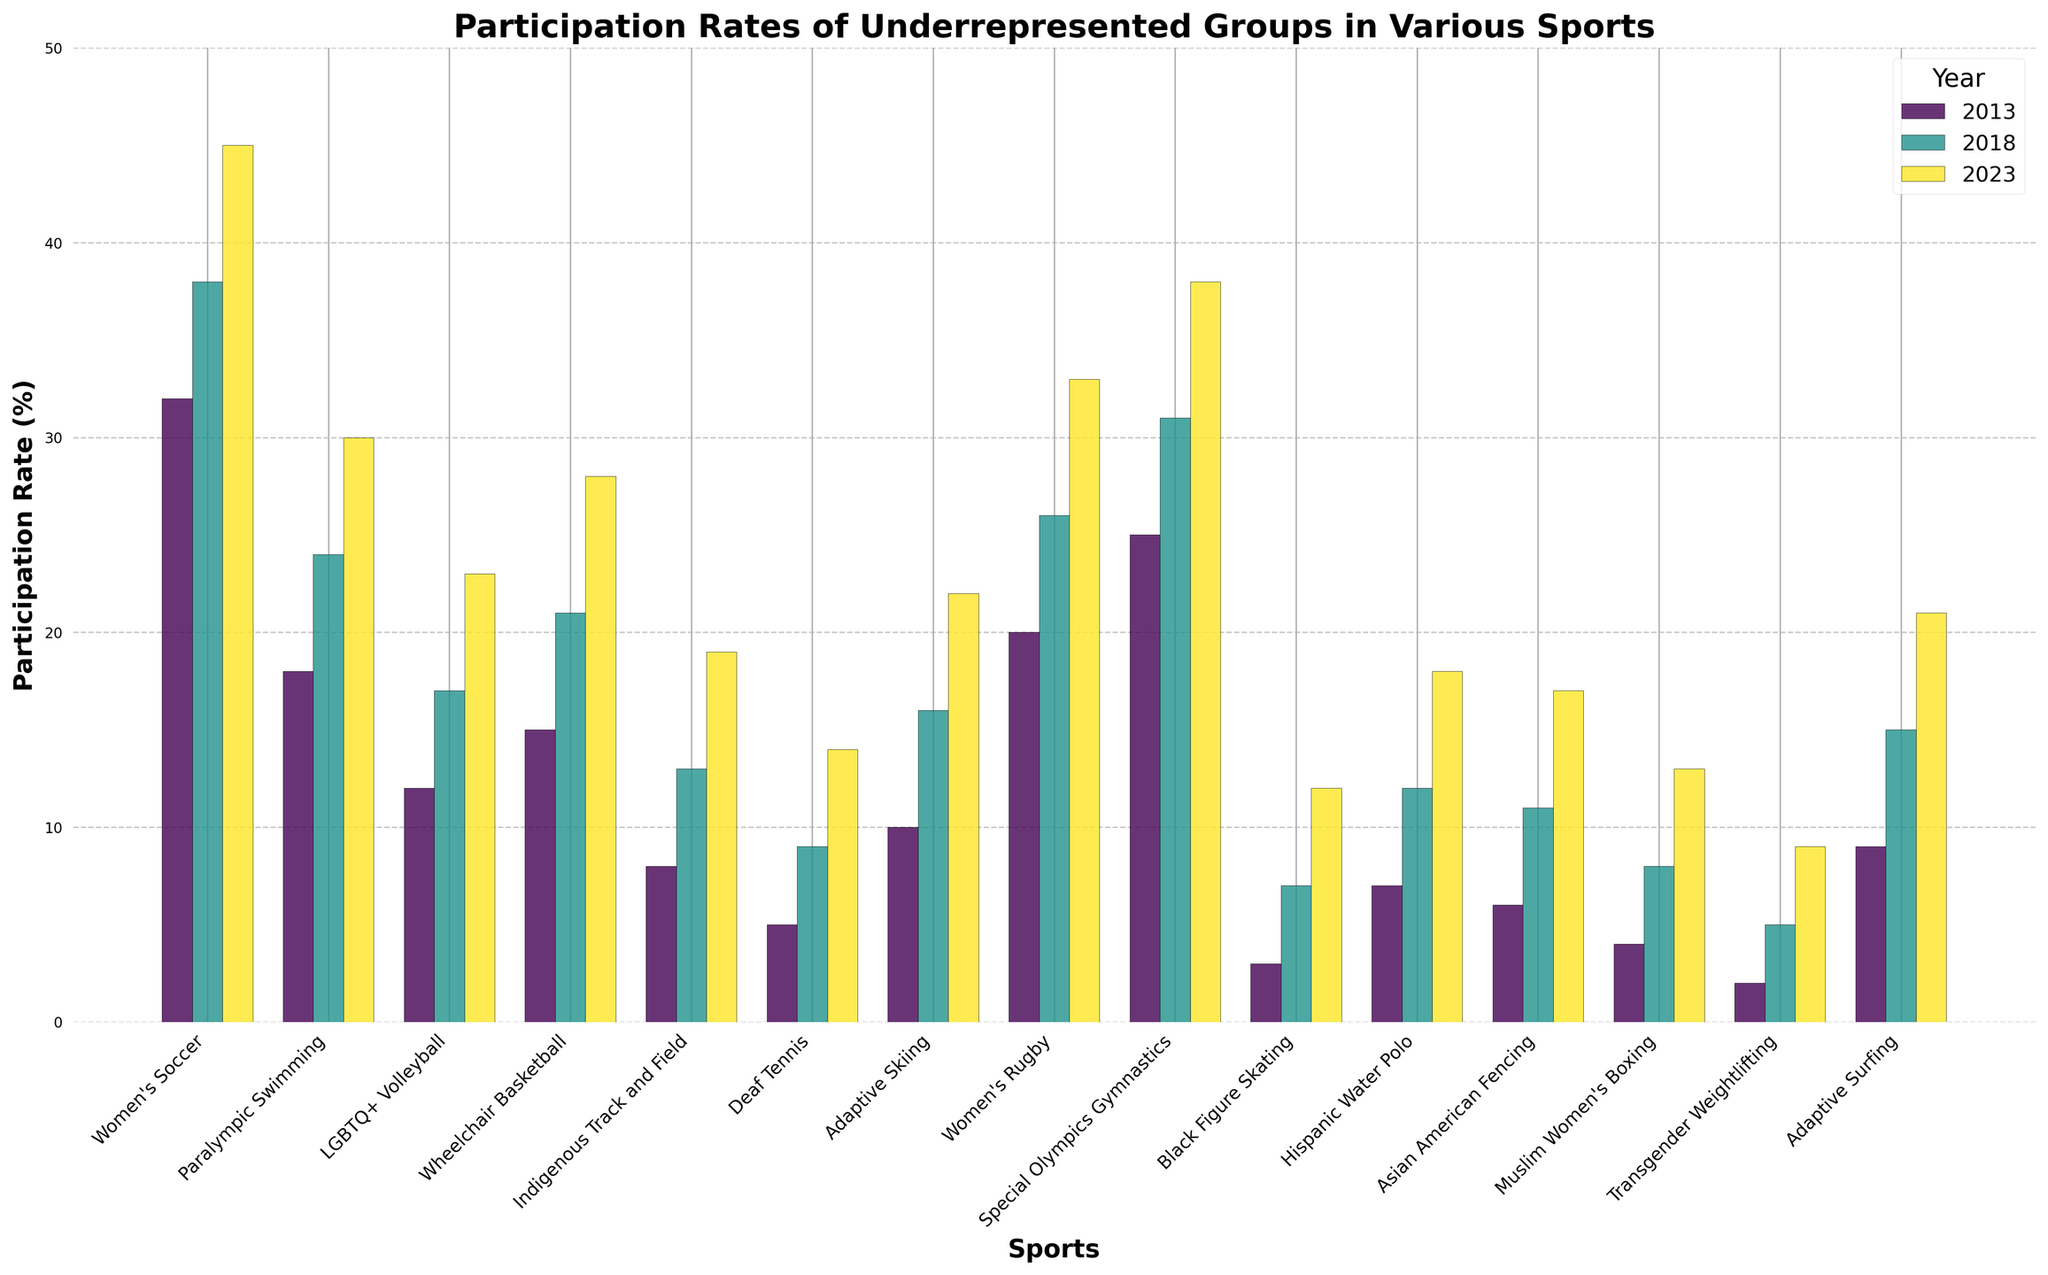What sport saw the largest increase in participation rate from 2013 to 2023? To find the sport with the largest increase in participation rate, calculate the difference between the 2023 and 2013 rates for each sport. The sport with the highest difference is the one with the largest increase. Women's Soccer increased from 32% to 45%, a 13% increase, which is the highest.
Answer: Women's Soccer Which sport had the highest participation rate in 2023? Look at the bar heights for the year 2023 across all sports. Special Olympics Gymnastics has the tallest bar in 2023, indicating the highest participation rate at 38%.
Answer: Special Olympics Gymnastics In which year did Paralympic Swimming have the lowest participation rate? Compare the heights of the bars for Paralympic Swimming across the three years: 2013, 2018, and 2023. The shortest bar corresponds to 2013, with an 18% participation rate.
Answer: 2013 How much did the participation rate for Adaptive Skiing increase between 2018 and 2023? Locate the bars for Adaptive Skiing in 2018 and 2023. Subtract the height of the 2018 bar (16%) from the 2023 bar (22%) to find the increase. 22% - 16% equals a 6% increase.
Answer: 6% Which sports had participation rates below 10% in 2013? Observe the bars for 2013 and identify those with heights below the 10% mark. Indigenous Track and Field, Deaf Tennis, Black Figure Skating, Hispanic Water Polo, Asian American Fencing, Muslim Women's Boxing, and Transgender Weightlifting all had participation rates below 10% in 2013.
Answer: Indigenous Track and Field, Deaf Tennis, Black Figure Skating, Hispanic Water Polo, Asian American Fencing, Muslim Women's Boxing, Transgender Weightlifting What is the average participation rate across all sports in 2023? Sum the participation rates for all sports in 2023 and divide by the number of sports (15). The sum is 364, and the average is 364/15, which equals roughly 24.27%.
Answer: 24.27% Which sport had the smallest increase in participation rate from 2013 to 2023? Calculate the difference between the 2023 and 2013 participation rates for each sport. The sport with the smallest increase will have the smallest difference. Black Figure Skating increased from 3% to 12%, a 9% increase, which is the smallest.
Answer: Black Figure Skating Are there any sports where participation rates doubled from 2013 to 2023? If so, which ones? For each sport, check if the participation rate in 2023 is at least twice the rate in 2013. For instance, Deaf Tennis increased from 5% to 14%, which is more than double, and Transgender Weightlifting increased from 2% to 9%, which is also more than double.
Answer: Deaf Tennis, Transgender Weightlifting Which two sports had the closest participation rates in 2023? Compare the 2023 bars' heights to identify the two closest values. Deaf Tennis (14%) and Muslim Women's Boxing (13%) have the closest rates, with just a 1% difference.
Answer: Deaf Tennis, Muslim Women's Boxing Among the sports listed, which one had the lowest participation rate in 2013 and how much did it increase by 2023? Identify the sport with the shortest bar in 2013 and note its value. Transgender Weightlifting had the lowest at 2%. Calculate the increase by subtracting the 2013 rate from the 2023 rate: 9% - 2% = 7% increase.
Answer: Transgender Weightlifting, 7% 